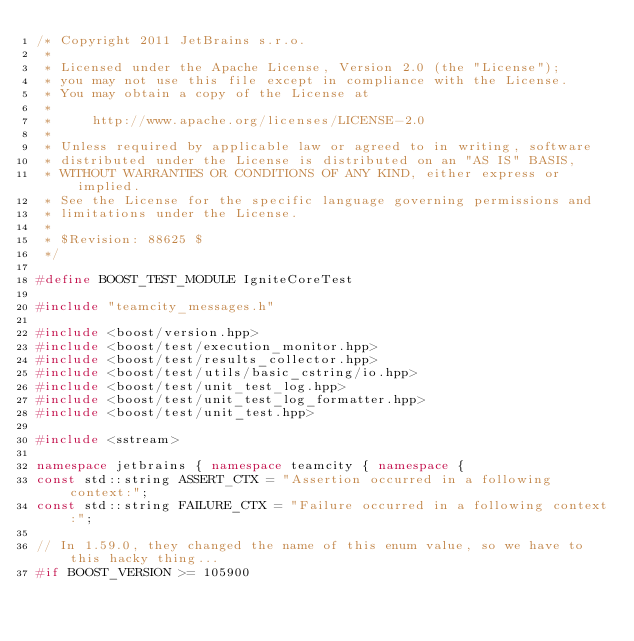<code> <loc_0><loc_0><loc_500><loc_500><_C++_>/* Copyright 2011 JetBrains s.r.o.
 *
 * Licensed under the Apache License, Version 2.0 (the "License");
 * you may not use this file except in compliance with the License.
 * You may obtain a copy of the License at
 *
 *     http://www.apache.org/licenses/LICENSE-2.0
 *
 * Unless required by applicable law or agreed to in writing, software
 * distributed under the License is distributed on an "AS IS" BASIS,
 * WITHOUT WARRANTIES OR CONDITIONS OF ANY KIND, either express or implied.
 * See the License for the specific language governing permissions and
 * limitations under the License.
 *
 * $Revision: 88625 $
 */

#define BOOST_TEST_MODULE IgniteCoreTest

#include "teamcity_messages.h"

#include <boost/version.hpp>
#include <boost/test/execution_monitor.hpp>
#include <boost/test/results_collector.hpp>
#include <boost/test/utils/basic_cstring/io.hpp>
#include <boost/test/unit_test_log.hpp>
#include <boost/test/unit_test_log_formatter.hpp>
#include <boost/test/unit_test.hpp>

#include <sstream>

namespace jetbrains { namespace teamcity { namespace {
const std::string ASSERT_CTX = "Assertion occurred in a following context:";
const std::string FAILURE_CTX = "Failure occurred in a following context:";

// In 1.59.0, they changed the name of this enum value, so we have to this hacky thing...
#if BOOST_VERSION >= 105900</code> 